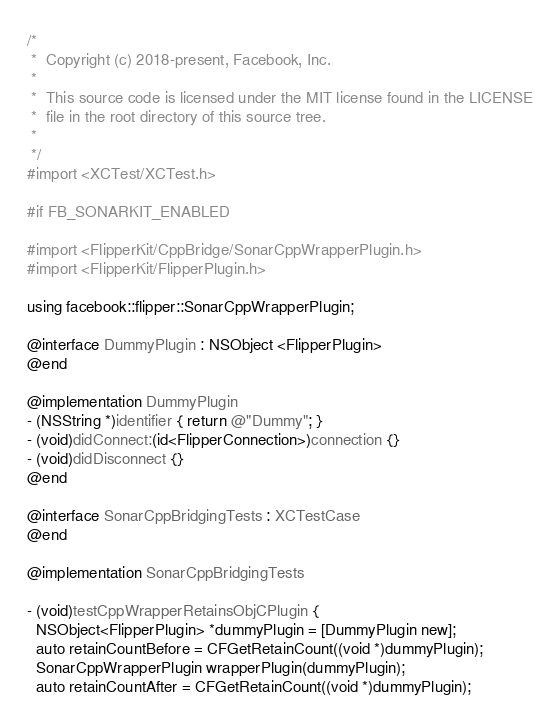Convert code to text. <code><loc_0><loc_0><loc_500><loc_500><_ObjectiveC_>/*
 *  Copyright (c) 2018-present, Facebook, Inc.
 *
 *  This source code is licensed under the MIT license found in the LICENSE
 *  file in the root directory of this source tree.
 *
 */
#import <XCTest/XCTest.h>

#if FB_SONARKIT_ENABLED

#import <FlipperKit/CppBridge/SonarCppWrapperPlugin.h>
#import <FlipperKit/FlipperPlugin.h>

using facebook::flipper::SonarCppWrapperPlugin;

@interface DummyPlugin : NSObject <FlipperPlugin>
@end

@implementation DummyPlugin
- (NSString *)identifier { return @"Dummy"; }
- (void)didConnect:(id<FlipperConnection>)connection {}
- (void)didDisconnect {}
@end

@interface SonarCppBridgingTests : XCTestCase
@end

@implementation SonarCppBridgingTests

- (void)testCppWrapperRetainsObjCPlugin {
  NSObject<FlipperPlugin> *dummyPlugin = [DummyPlugin new];
  auto retainCountBefore = CFGetRetainCount((void *)dummyPlugin);
  SonarCppWrapperPlugin wrapperPlugin(dummyPlugin);
  auto retainCountAfter = CFGetRetainCount((void *)dummyPlugin);</code> 